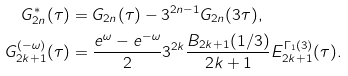<formula> <loc_0><loc_0><loc_500><loc_500>G _ { 2 n } ^ { * } ( \tau ) & = G _ { 2 n } ( \tau ) - 3 ^ { 2 n - 1 } G _ { 2 n } ( 3 \tau ) , \\ G _ { 2 k + 1 } ^ { ( - \omega ) } ( \tau ) & = \frac { e ^ { \omega } - e ^ { - \omega } } { 2 } 3 ^ { 2 k } \frac { B _ { 2 k + 1 } ( 1 / 3 ) } { 2 k + 1 } E _ { 2 k + 1 } ^ { \Gamma _ { 1 } ( 3 ) } ( \tau ) . \\</formula> 